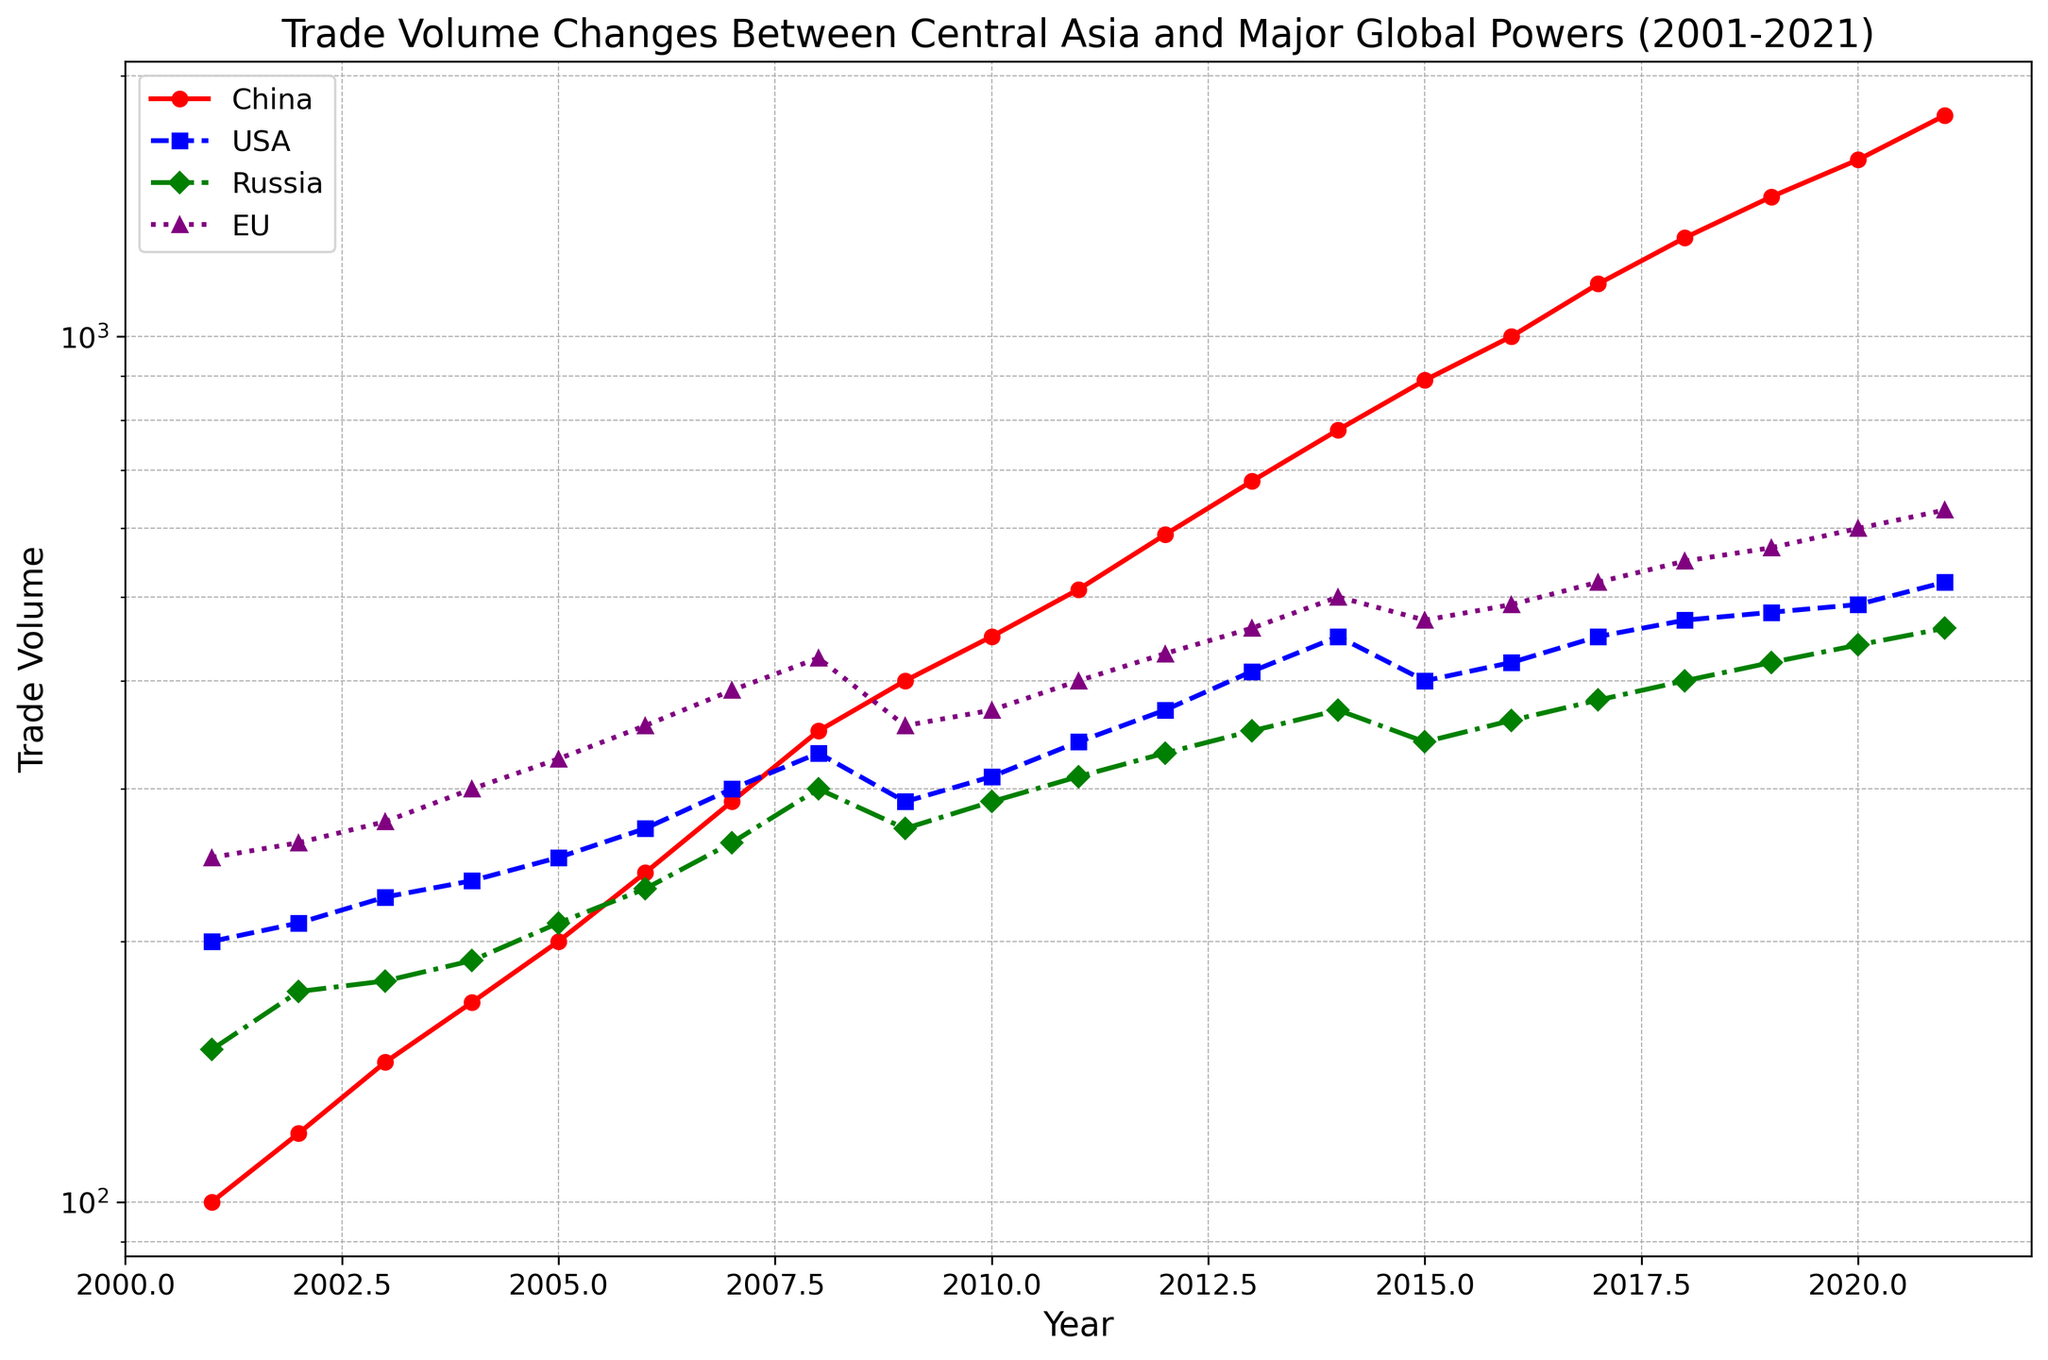What does the log scale on the y-axis tell us about the trends in trade volume changes over time? The log scale means that changes in the y-axis represent multiplicative rather than additive changes. A straight line on this plot would indicate exponential growth. By observing the curves, we can infer how the trade volumes have grown exponentially over time for each global power.
Answer: The log scale indicates exponential growth Which country has shown the most significant increase in trade volume with Central Asia from 2001 to 2021? By visually inspecting the plot, we see that the line for China (red, with circles) has the steepest upward trajectory. This indicates that China's trade volume has increased the most significantly over the past 20 years.
Answer: China By how much did the trade volume between Central Asia and the USA change from 2008 to 2009? The USA (blue, with squares) saw a decrease from 330 in 2008 to 290 in 2009. The change can be calculated as 330 - 290.
Answer: 40 How does the trade volume change between Central Asia and Russia compare to that of the EU over the entire time period? Visually comparing the lines for Russia (green, with diamonds) and the EU (purple, with triangles), the EU's trade volume is generally higher and shows a steadier increase compared to Russia.
Answer: The EU’s trade volume is higher During which year did China’s trade volume with Central Asia first exceed 1000 units? By inspecting China’s line (red, with circles), it first exceeds the 1000 mark in 2016.
Answer: 2016 How does the trade volume between Central Asia and Russia in 2020 compare to that in 2001? Russia’s trade volume is 440 in 2020 and 150 in 2001. The ratio is 440 / 150.
Answer: 2.93 times Which year shows the smallest trade volume difference between the USA and the EU? By visually comparing the distances between the blue line (USA) and the purple line (EU), the year 2002 has the smallest gap.
Answer: 2002 If you were to approximate the average trade volume of China over the first 10 years, what would it be? Sum the values for China from 2001 to 2010 (100+120+145+170+200+240+290+350+400+450) and divide by 10.
Answer: 246.5 Between 2016 and 2021, which global power consistently surpassed others in trade volume with Central Asia? By inspecting the plot, China (red, with circles) consistently surpasses other global powers during this period.
Answer: China In which year did the EU's trade volume with Central Asia surpass 500 units? By examining the EU curve (purple, with triangles), it surpasses 500 units in 2014.
Answer: 2014 Which country showed the least variance in trade volume over the 20-year period, and how can you tell? The USA (blue, with squares) line shows the least steep slopes and fluctuations compared to the other lines, indicating less variance.
Answer: USA 